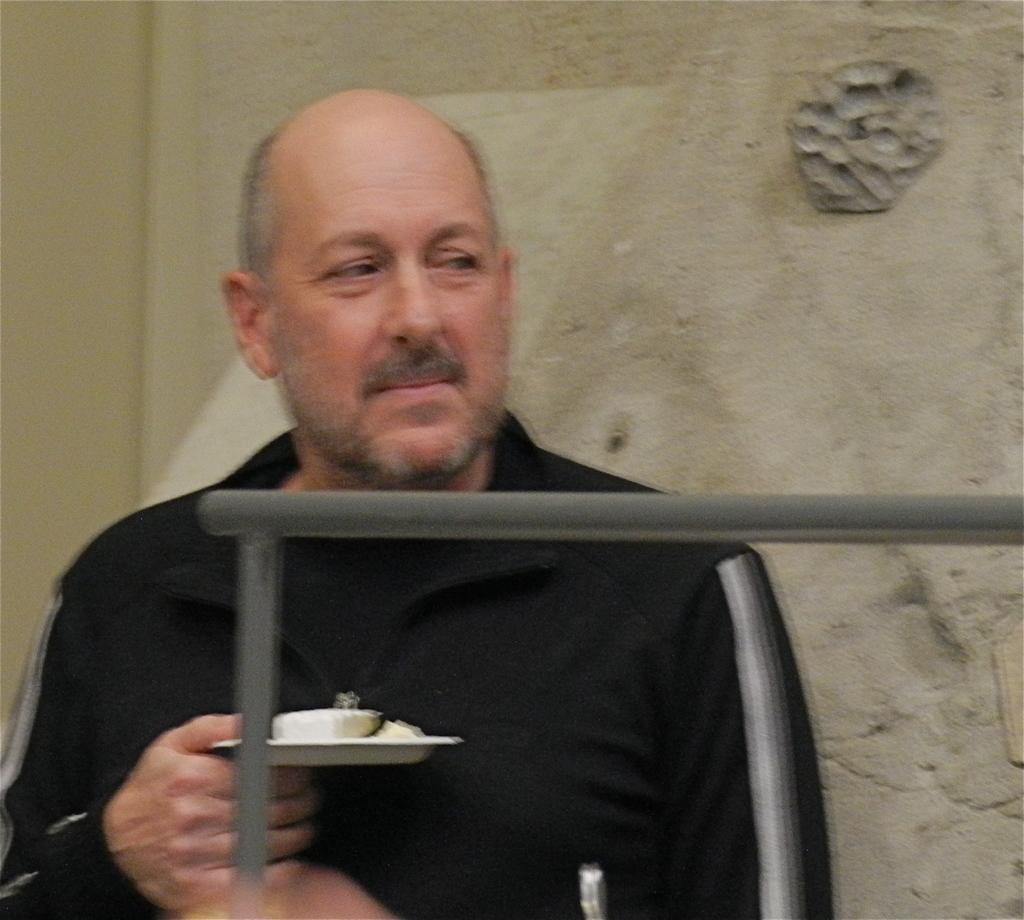In one or two sentences, can you explain what this image depicts? In this image we can see a person and holding an object in his hand. There is a metallic object in the image. There is a wall in the image. 